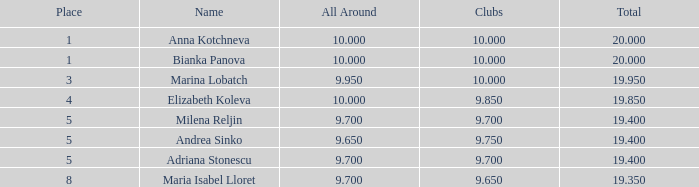What are the minimal clubs possessing a spot greater than 5, with an aggregate surpassing None. 